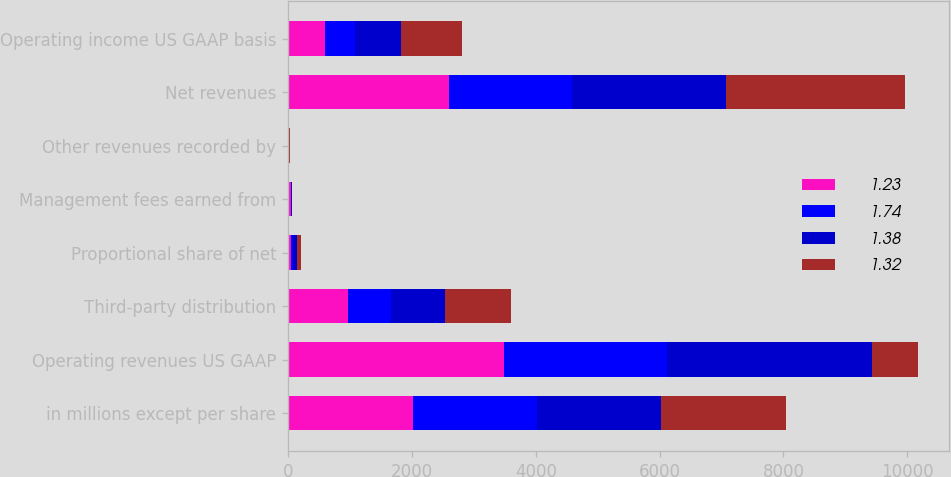Convert chart. <chart><loc_0><loc_0><loc_500><loc_500><stacked_bar_chart><ecel><fcel>in millions except per share<fcel>Operating revenues US GAAP<fcel>Third-party distribution<fcel>Proportional share of net<fcel>Management fees earned from<fcel>Other revenues recorded by<fcel>Net revenues<fcel>Operating income US GAAP basis<nl><fcel>1.23<fcel>2010<fcel>3487.7<fcel>972.7<fcel>42.2<fcel>45.3<fcel>0.3<fcel>2602.2<fcel>589.9<nl><fcel>1.74<fcel>2009<fcel>2627.3<fcel>693.4<fcel>44.7<fcel>8<fcel>2<fcel>1984.6<fcel>484.3<nl><fcel>1.38<fcel>2008<fcel>3307.6<fcel>875.5<fcel>57.3<fcel>6.2<fcel>5.4<fcel>2490.2<fcel>747.8<nl><fcel>1.32<fcel>2007<fcel>747.8<fcel>1051.1<fcel>60.6<fcel>8.7<fcel>15.2<fcel>2881.9<fcel>994.3<nl></chart> 